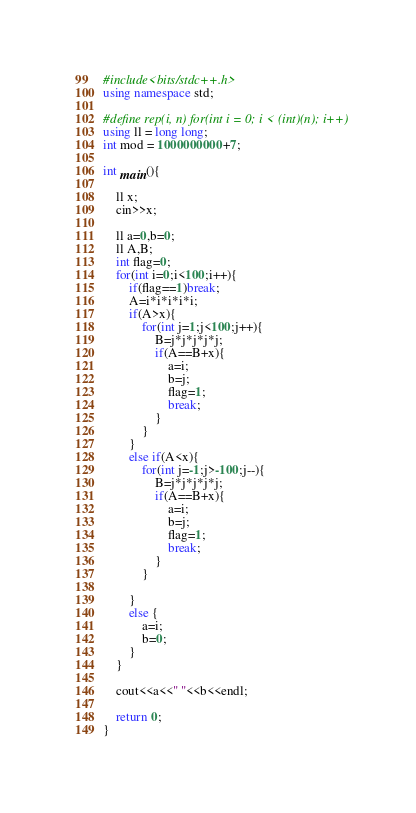<code> <loc_0><loc_0><loc_500><loc_500><_C++_>#include<bits/stdc++.h>
using namespace std;

#define rep(i, n) for(int i = 0; i < (int)(n); i++)
using ll = long long;
int mod = 1000000000+7;

int main(){

    ll x;
    cin>>x;

    ll a=0,b=0;
    ll A,B;
    int flag=0;
    for(int i=0;i<100;i++){
        if(flag==1)break;
        A=i*i*i*i*i;
        if(A>x){
            for(int j=1;j<100;j++){
                B=j*j*j*j*j;
                if(A==B+x){
                    a=i;
                    b=j;
                    flag=1;
                    break;
                }
            }
        }
        else if(A<x){
            for(int j=-1;j>-100;j--){
                B=j*j*j*j*j;
                if(A==B+x){
                    a=i;
                    b=j;
                    flag=1;
                    break;
                }
            }

        }
        else {
            a=i;
            b=0;
        }
    }

    cout<<a<<" "<<b<<endl;

    return 0;
}</code> 